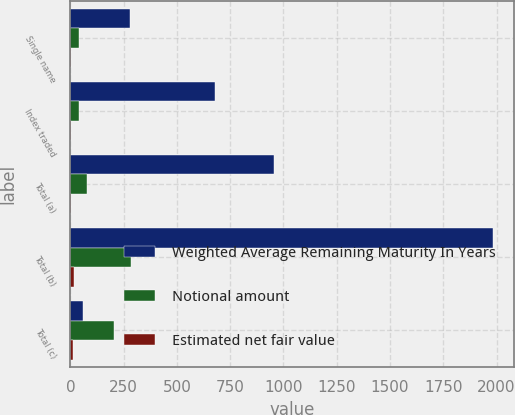Convert chart. <chart><loc_0><loc_0><loc_500><loc_500><stacked_bar_chart><ecel><fcel>Single name<fcel>Index traded<fcel>Total (a)<fcel>Total (b)<fcel>Total (c)<nl><fcel>Weighted Average Remaining Maturity In Years<fcel>278<fcel>677<fcel>955<fcel>1982<fcel>61<nl><fcel>Notional amount<fcel>38<fcel>42<fcel>80<fcel>285<fcel>205<nl><fcel>Estimated net fair value<fcel>3.84<fcel>4.84<fcel>4.54<fcel>18.06<fcel>13.67<nl></chart> 